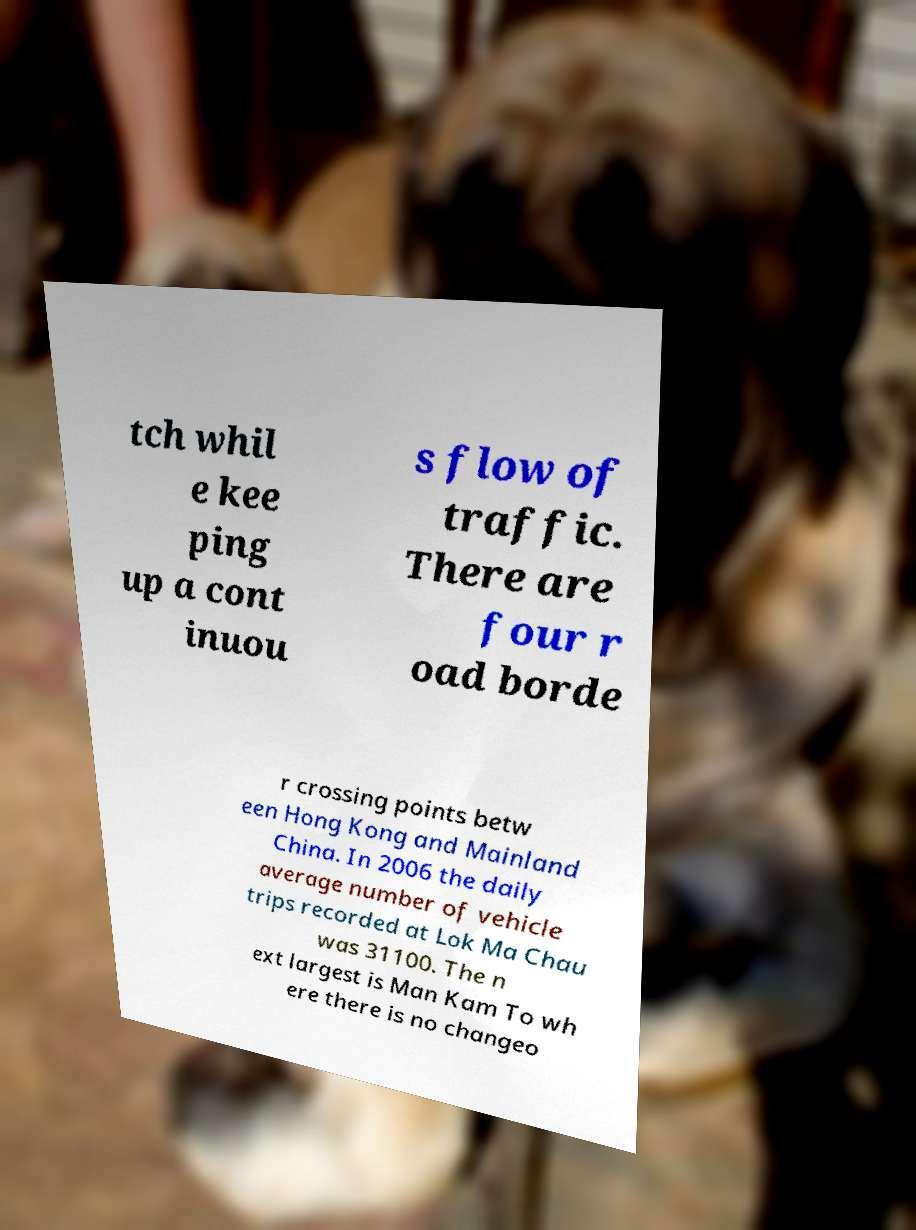Please read and relay the text visible in this image. What does it say? tch whil e kee ping up a cont inuou s flow of traffic. There are four r oad borde r crossing points betw een Hong Kong and Mainland China. In 2006 the daily average number of vehicle trips recorded at Lok Ma Chau was 31100. The n ext largest is Man Kam To wh ere there is no changeo 